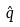Convert formula to latex. <formula><loc_0><loc_0><loc_500><loc_500>\hat { q }</formula> 